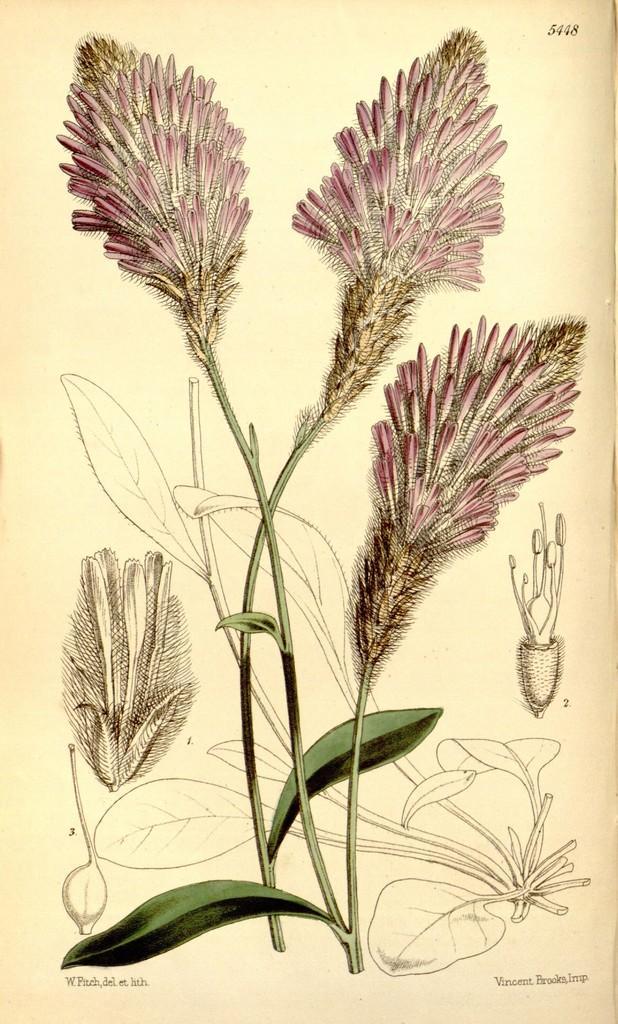Could you give a brief overview of what you see in this image? In this image we can see the picture of a plant with flowers and some text on it. 